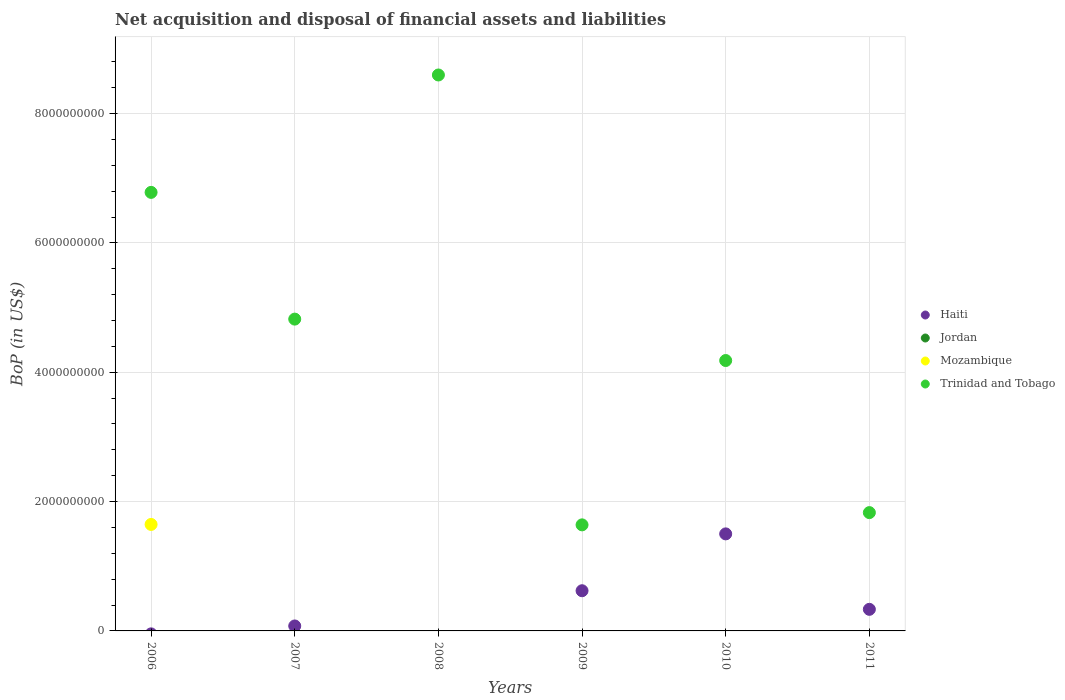How many different coloured dotlines are there?
Ensure brevity in your answer.  3. Is the number of dotlines equal to the number of legend labels?
Keep it short and to the point. No. What is the Balance of Payments in Haiti in 2006?
Your response must be concise. 0. Across all years, what is the maximum Balance of Payments in Haiti?
Offer a terse response. 1.50e+09. Across all years, what is the minimum Balance of Payments in Trinidad and Tobago?
Your response must be concise. 1.64e+09. What is the total Balance of Payments in Haiti in the graph?
Your response must be concise. 2.53e+09. What is the difference between the Balance of Payments in Haiti in 2009 and that in 2011?
Your answer should be compact. 2.88e+08. What is the difference between the Balance of Payments in Trinidad and Tobago in 2011 and the Balance of Payments in Haiti in 2008?
Your response must be concise. 1.83e+09. What is the average Balance of Payments in Jordan per year?
Your response must be concise. 0. In the year 2011, what is the difference between the Balance of Payments in Haiti and Balance of Payments in Trinidad and Tobago?
Ensure brevity in your answer.  -1.50e+09. What is the ratio of the Balance of Payments in Haiti in 2007 to that in 2009?
Make the answer very short. 0.12. Is the Balance of Payments in Trinidad and Tobago in 2006 less than that in 2008?
Offer a very short reply. Yes. What is the difference between the highest and the second highest Balance of Payments in Trinidad and Tobago?
Give a very brief answer. 1.82e+09. What is the difference between the highest and the lowest Balance of Payments in Mozambique?
Keep it short and to the point. 1.65e+09. Is the sum of the Balance of Payments in Haiti in 2009 and 2011 greater than the maximum Balance of Payments in Trinidad and Tobago across all years?
Make the answer very short. No. Is it the case that in every year, the sum of the Balance of Payments in Haiti and Balance of Payments in Jordan  is greater than the sum of Balance of Payments in Trinidad and Tobago and Balance of Payments in Mozambique?
Make the answer very short. No. Does the Balance of Payments in Haiti monotonically increase over the years?
Provide a short and direct response. No. Is the Balance of Payments in Jordan strictly greater than the Balance of Payments in Trinidad and Tobago over the years?
Your response must be concise. No. How many dotlines are there?
Make the answer very short. 3. How many years are there in the graph?
Make the answer very short. 6. What is the difference between two consecutive major ticks on the Y-axis?
Your answer should be compact. 2.00e+09. How are the legend labels stacked?
Offer a terse response. Vertical. What is the title of the graph?
Your response must be concise. Net acquisition and disposal of financial assets and liabilities. Does "Luxembourg" appear as one of the legend labels in the graph?
Your response must be concise. No. What is the label or title of the Y-axis?
Your answer should be compact. BoP (in US$). What is the BoP (in US$) in Mozambique in 2006?
Make the answer very short. 1.65e+09. What is the BoP (in US$) of Trinidad and Tobago in 2006?
Provide a short and direct response. 6.78e+09. What is the BoP (in US$) of Haiti in 2007?
Offer a terse response. 7.68e+07. What is the BoP (in US$) in Mozambique in 2007?
Make the answer very short. 0. What is the BoP (in US$) in Trinidad and Tobago in 2007?
Ensure brevity in your answer.  4.82e+09. What is the BoP (in US$) of Haiti in 2008?
Give a very brief answer. 0. What is the BoP (in US$) in Jordan in 2008?
Ensure brevity in your answer.  0. What is the BoP (in US$) in Trinidad and Tobago in 2008?
Your response must be concise. 8.60e+09. What is the BoP (in US$) in Haiti in 2009?
Offer a terse response. 6.21e+08. What is the BoP (in US$) in Jordan in 2009?
Ensure brevity in your answer.  0. What is the BoP (in US$) in Trinidad and Tobago in 2009?
Your answer should be very brief. 1.64e+09. What is the BoP (in US$) in Haiti in 2010?
Provide a succinct answer. 1.50e+09. What is the BoP (in US$) of Trinidad and Tobago in 2010?
Offer a terse response. 4.18e+09. What is the BoP (in US$) in Haiti in 2011?
Keep it short and to the point. 3.34e+08. What is the BoP (in US$) of Mozambique in 2011?
Your answer should be compact. 0. What is the BoP (in US$) in Trinidad and Tobago in 2011?
Your answer should be very brief. 1.83e+09. Across all years, what is the maximum BoP (in US$) of Haiti?
Provide a succinct answer. 1.50e+09. Across all years, what is the maximum BoP (in US$) of Mozambique?
Provide a succinct answer. 1.65e+09. Across all years, what is the maximum BoP (in US$) in Trinidad and Tobago?
Make the answer very short. 8.60e+09. Across all years, what is the minimum BoP (in US$) in Mozambique?
Ensure brevity in your answer.  0. Across all years, what is the minimum BoP (in US$) of Trinidad and Tobago?
Your response must be concise. 1.64e+09. What is the total BoP (in US$) in Haiti in the graph?
Make the answer very short. 2.53e+09. What is the total BoP (in US$) in Jordan in the graph?
Your answer should be compact. 0. What is the total BoP (in US$) in Mozambique in the graph?
Make the answer very short. 1.65e+09. What is the total BoP (in US$) in Trinidad and Tobago in the graph?
Ensure brevity in your answer.  2.78e+1. What is the difference between the BoP (in US$) of Trinidad and Tobago in 2006 and that in 2007?
Provide a succinct answer. 1.96e+09. What is the difference between the BoP (in US$) in Trinidad and Tobago in 2006 and that in 2008?
Offer a terse response. -1.82e+09. What is the difference between the BoP (in US$) in Trinidad and Tobago in 2006 and that in 2009?
Provide a short and direct response. 5.14e+09. What is the difference between the BoP (in US$) of Trinidad and Tobago in 2006 and that in 2010?
Provide a short and direct response. 2.60e+09. What is the difference between the BoP (in US$) in Trinidad and Tobago in 2006 and that in 2011?
Make the answer very short. 4.95e+09. What is the difference between the BoP (in US$) in Trinidad and Tobago in 2007 and that in 2008?
Keep it short and to the point. -3.77e+09. What is the difference between the BoP (in US$) of Haiti in 2007 and that in 2009?
Your answer should be very brief. -5.45e+08. What is the difference between the BoP (in US$) of Trinidad and Tobago in 2007 and that in 2009?
Your response must be concise. 3.18e+09. What is the difference between the BoP (in US$) of Haiti in 2007 and that in 2010?
Provide a short and direct response. -1.42e+09. What is the difference between the BoP (in US$) of Trinidad and Tobago in 2007 and that in 2010?
Ensure brevity in your answer.  6.40e+08. What is the difference between the BoP (in US$) of Haiti in 2007 and that in 2011?
Offer a very short reply. -2.57e+08. What is the difference between the BoP (in US$) of Trinidad and Tobago in 2007 and that in 2011?
Ensure brevity in your answer.  2.99e+09. What is the difference between the BoP (in US$) in Trinidad and Tobago in 2008 and that in 2009?
Offer a very short reply. 6.96e+09. What is the difference between the BoP (in US$) of Trinidad and Tobago in 2008 and that in 2010?
Your response must be concise. 4.42e+09. What is the difference between the BoP (in US$) in Trinidad and Tobago in 2008 and that in 2011?
Give a very brief answer. 6.77e+09. What is the difference between the BoP (in US$) in Haiti in 2009 and that in 2010?
Your answer should be compact. -8.79e+08. What is the difference between the BoP (in US$) in Trinidad and Tobago in 2009 and that in 2010?
Give a very brief answer. -2.54e+09. What is the difference between the BoP (in US$) in Haiti in 2009 and that in 2011?
Your answer should be very brief. 2.88e+08. What is the difference between the BoP (in US$) in Trinidad and Tobago in 2009 and that in 2011?
Keep it short and to the point. -1.89e+08. What is the difference between the BoP (in US$) of Haiti in 2010 and that in 2011?
Your answer should be compact. 1.17e+09. What is the difference between the BoP (in US$) in Trinidad and Tobago in 2010 and that in 2011?
Keep it short and to the point. 2.35e+09. What is the difference between the BoP (in US$) in Mozambique in 2006 and the BoP (in US$) in Trinidad and Tobago in 2007?
Provide a succinct answer. -3.17e+09. What is the difference between the BoP (in US$) of Mozambique in 2006 and the BoP (in US$) of Trinidad and Tobago in 2008?
Provide a short and direct response. -6.95e+09. What is the difference between the BoP (in US$) in Mozambique in 2006 and the BoP (in US$) in Trinidad and Tobago in 2009?
Your response must be concise. 6.50e+06. What is the difference between the BoP (in US$) in Mozambique in 2006 and the BoP (in US$) in Trinidad and Tobago in 2010?
Offer a very short reply. -2.53e+09. What is the difference between the BoP (in US$) in Mozambique in 2006 and the BoP (in US$) in Trinidad and Tobago in 2011?
Your response must be concise. -1.83e+08. What is the difference between the BoP (in US$) in Haiti in 2007 and the BoP (in US$) in Trinidad and Tobago in 2008?
Make the answer very short. -8.52e+09. What is the difference between the BoP (in US$) in Haiti in 2007 and the BoP (in US$) in Trinidad and Tobago in 2009?
Provide a succinct answer. -1.56e+09. What is the difference between the BoP (in US$) of Haiti in 2007 and the BoP (in US$) of Trinidad and Tobago in 2010?
Your response must be concise. -4.10e+09. What is the difference between the BoP (in US$) of Haiti in 2007 and the BoP (in US$) of Trinidad and Tobago in 2011?
Give a very brief answer. -1.75e+09. What is the difference between the BoP (in US$) in Haiti in 2009 and the BoP (in US$) in Trinidad and Tobago in 2010?
Provide a short and direct response. -3.56e+09. What is the difference between the BoP (in US$) in Haiti in 2009 and the BoP (in US$) in Trinidad and Tobago in 2011?
Offer a terse response. -1.21e+09. What is the difference between the BoP (in US$) in Haiti in 2010 and the BoP (in US$) in Trinidad and Tobago in 2011?
Provide a short and direct response. -3.29e+08. What is the average BoP (in US$) in Haiti per year?
Offer a terse response. 4.22e+08. What is the average BoP (in US$) in Mozambique per year?
Provide a succinct answer. 2.74e+08. What is the average BoP (in US$) of Trinidad and Tobago per year?
Make the answer very short. 4.64e+09. In the year 2006, what is the difference between the BoP (in US$) of Mozambique and BoP (in US$) of Trinidad and Tobago?
Ensure brevity in your answer.  -5.13e+09. In the year 2007, what is the difference between the BoP (in US$) in Haiti and BoP (in US$) in Trinidad and Tobago?
Provide a short and direct response. -4.74e+09. In the year 2009, what is the difference between the BoP (in US$) in Haiti and BoP (in US$) in Trinidad and Tobago?
Make the answer very short. -1.02e+09. In the year 2010, what is the difference between the BoP (in US$) of Haiti and BoP (in US$) of Trinidad and Tobago?
Your answer should be very brief. -2.68e+09. In the year 2011, what is the difference between the BoP (in US$) of Haiti and BoP (in US$) of Trinidad and Tobago?
Make the answer very short. -1.50e+09. What is the ratio of the BoP (in US$) of Trinidad and Tobago in 2006 to that in 2007?
Your response must be concise. 1.41. What is the ratio of the BoP (in US$) in Trinidad and Tobago in 2006 to that in 2008?
Keep it short and to the point. 0.79. What is the ratio of the BoP (in US$) of Trinidad and Tobago in 2006 to that in 2009?
Offer a very short reply. 4.13. What is the ratio of the BoP (in US$) in Trinidad and Tobago in 2006 to that in 2010?
Keep it short and to the point. 1.62. What is the ratio of the BoP (in US$) of Trinidad and Tobago in 2006 to that in 2011?
Provide a succinct answer. 3.71. What is the ratio of the BoP (in US$) of Trinidad and Tobago in 2007 to that in 2008?
Your answer should be very brief. 0.56. What is the ratio of the BoP (in US$) of Haiti in 2007 to that in 2009?
Ensure brevity in your answer.  0.12. What is the ratio of the BoP (in US$) of Trinidad and Tobago in 2007 to that in 2009?
Your answer should be very brief. 2.94. What is the ratio of the BoP (in US$) in Haiti in 2007 to that in 2010?
Give a very brief answer. 0.05. What is the ratio of the BoP (in US$) in Trinidad and Tobago in 2007 to that in 2010?
Offer a very short reply. 1.15. What is the ratio of the BoP (in US$) in Haiti in 2007 to that in 2011?
Keep it short and to the point. 0.23. What is the ratio of the BoP (in US$) of Trinidad and Tobago in 2007 to that in 2011?
Provide a succinct answer. 2.64. What is the ratio of the BoP (in US$) in Trinidad and Tobago in 2008 to that in 2009?
Give a very brief answer. 5.24. What is the ratio of the BoP (in US$) of Trinidad and Tobago in 2008 to that in 2010?
Keep it short and to the point. 2.06. What is the ratio of the BoP (in US$) in Trinidad and Tobago in 2008 to that in 2011?
Give a very brief answer. 4.7. What is the ratio of the BoP (in US$) in Haiti in 2009 to that in 2010?
Your answer should be very brief. 0.41. What is the ratio of the BoP (in US$) in Trinidad and Tobago in 2009 to that in 2010?
Make the answer very short. 0.39. What is the ratio of the BoP (in US$) in Haiti in 2009 to that in 2011?
Ensure brevity in your answer.  1.86. What is the ratio of the BoP (in US$) of Trinidad and Tobago in 2009 to that in 2011?
Offer a terse response. 0.9. What is the ratio of the BoP (in US$) in Haiti in 2010 to that in 2011?
Provide a succinct answer. 4.5. What is the ratio of the BoP (in US$) in Trinidad and Tobago in 2010 to that in 2011?
Offer a very short reply. 2.29. What is the difference between the highest and the second highest BoP (in US$) of Haiti?
Provide a short and direct response. 8.79e+08. What is the difference between the highest and the second highest BoP (in US$) of Trinidad and Tobago?
Offer a terse response. 1.82e+09. What is the difference between the highest and the lowest BoP (in US$) in Haiti?
Provide a short and direct response. 1.50e+09. What is the difference between the highest and the lowest BoP (in US$) of Mozambique?
Offer a very short reply. 1.65e+09. What is the difference between the highest and the lowest BoP (in US$) in Trinidad and Tobago?
Give a very brief answer. 6.96e+09. 